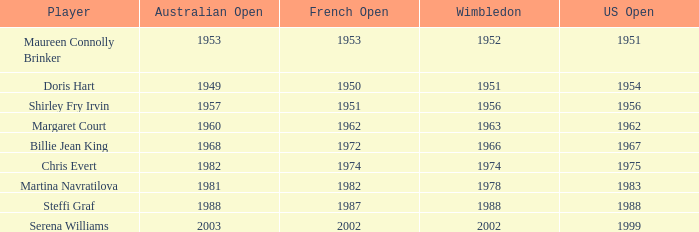What year did Martina Navratilova win Wimbledon? 1978.0. 